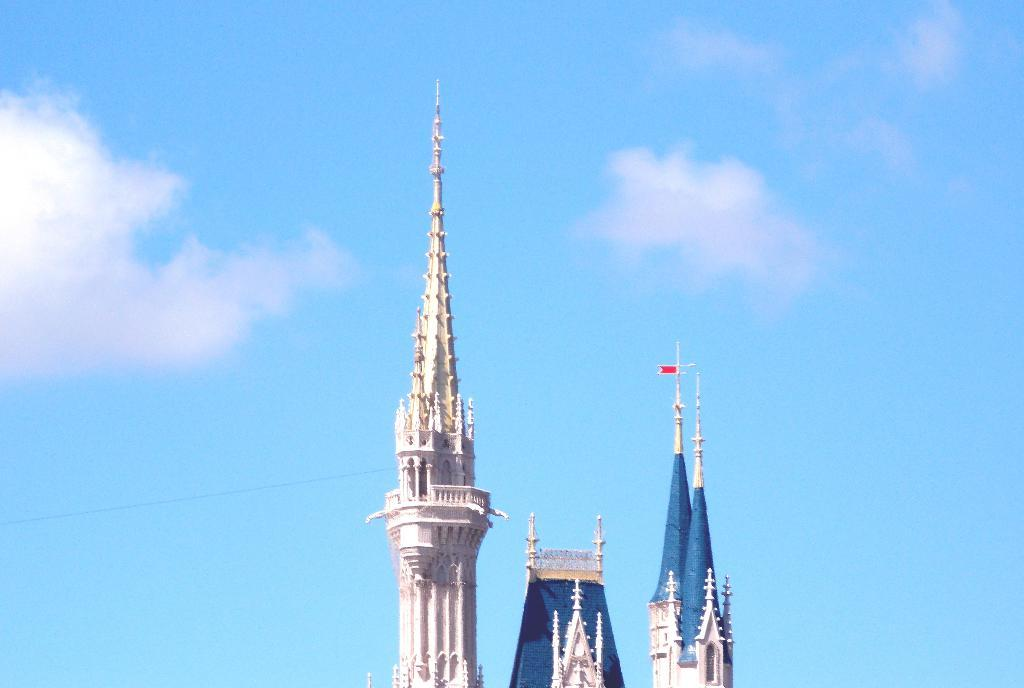What type of structure is visible in the image? The image shows the top of a building. What is the color of the sky in the image? The sky is blue in color. What is the weather condition in the image? The sky is cloudy in the image. What type of steel is being used to construct the building in the image? There is no information about the type of steel being used in the image. What book is the person reading while standing on the building in the image? There is no person or book visible in the image. 